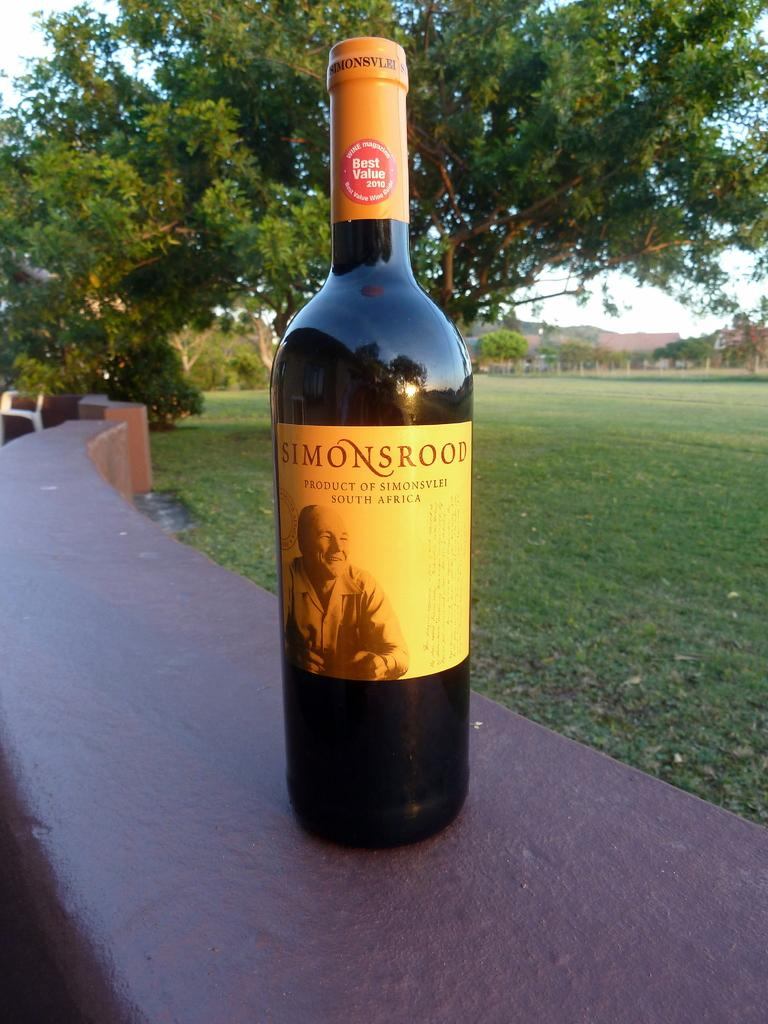<image>
Describe the image concisely. simonsrood wine is sitting on the top of a wall 